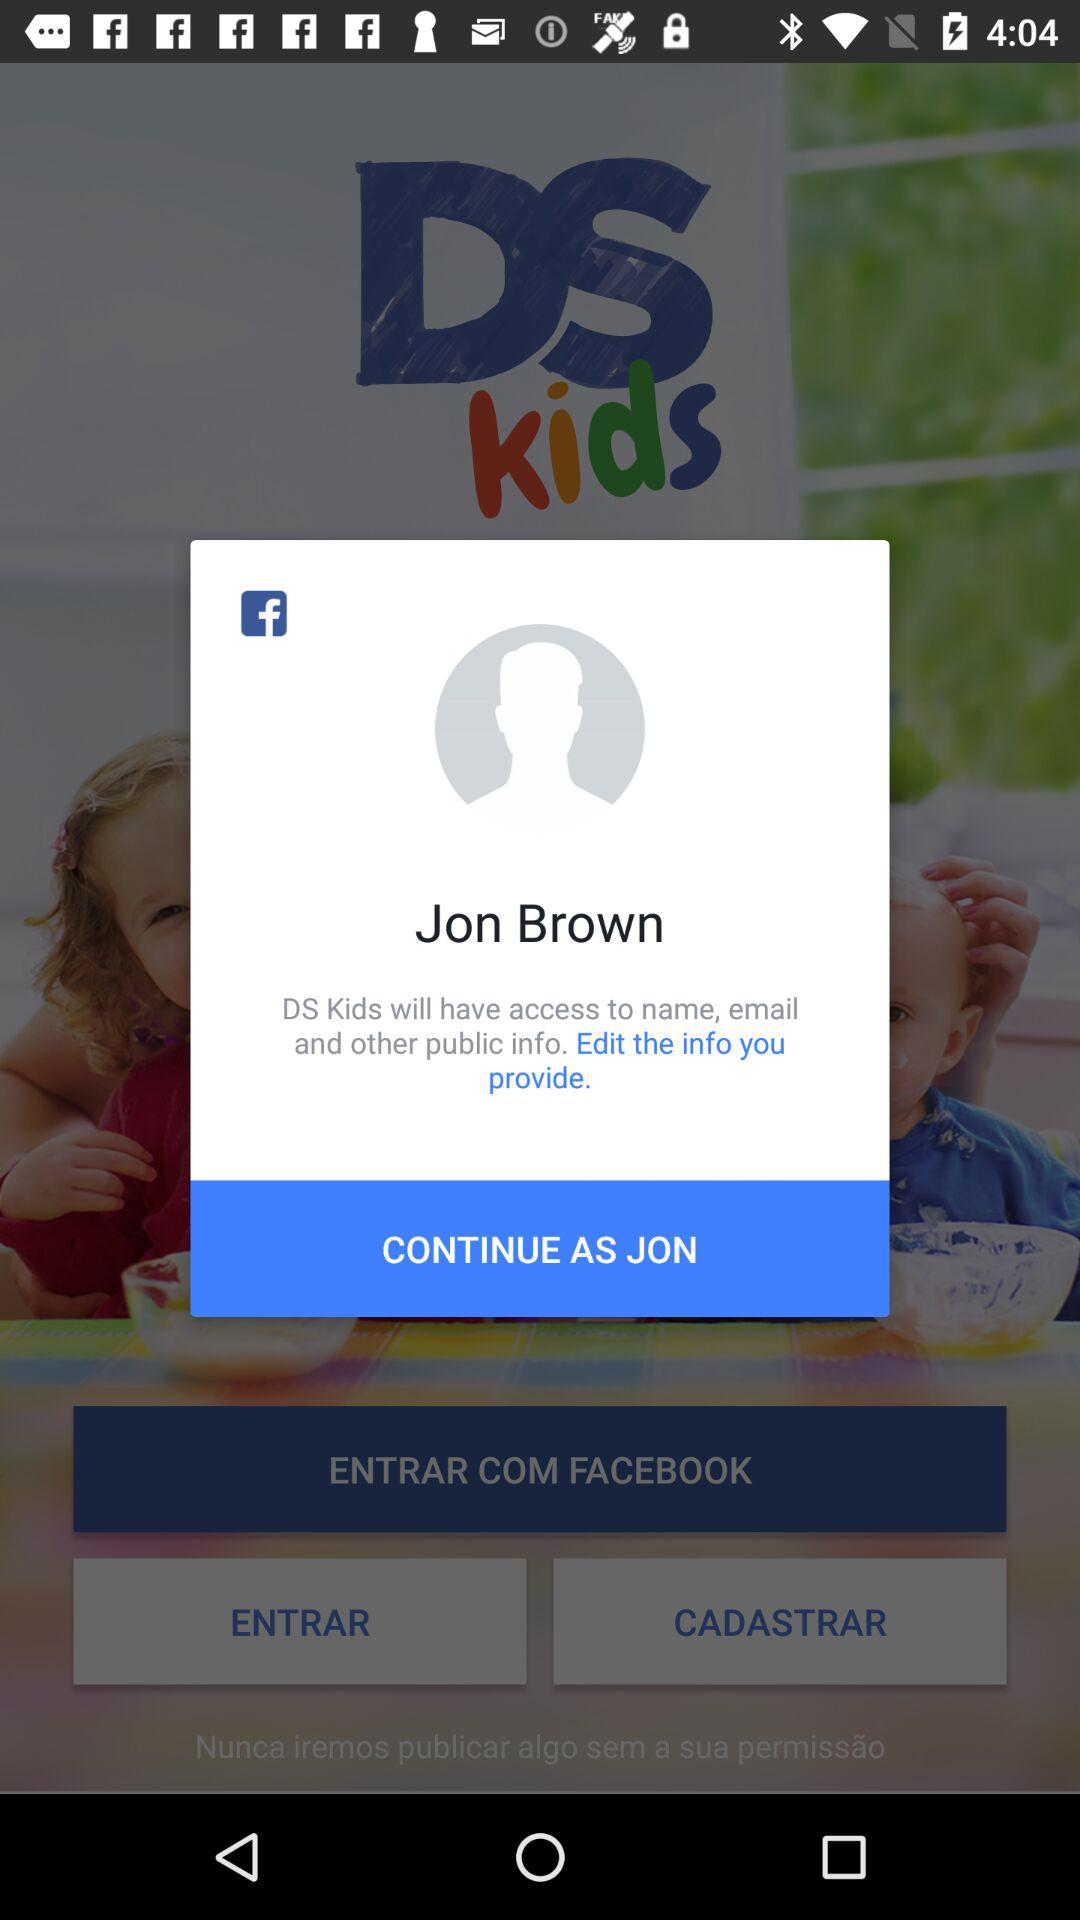What is the user name to continue the profile? The user name is Jon Brown. 